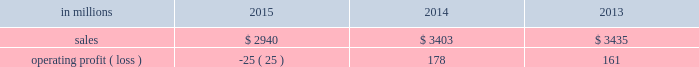Augusta , georgia mill and $ 2 million of costs associated with the sale of the shorewood business .
Consumer packaging .
North american consumer packaging net sales were $ 1.9 billion in 2015 compared with $ 2.0 billion in 2014 and $ 2.0 billion in 2013 .
Operating profits were $ 81 million ( $ 91 million excluding the cost associated with the planned conversion of our riegelwood mill to 100% ( 100 % ) pulp production , net of proceeds from the sale of the carolina coated bristols brand , and sheet plant closure costs ) in 2015 compared with $ 92 million ( $ 100 million excluding sheet plant closure costs ) in 2014 and $ 63 million ( $ 110 million excluding paper machine shutdown costs and costs related to the sale of the shorewood business ) in 2013 .
Coated paperboard sales volumes in 2015 were lower than in 2014 reflecting weaker market demand .
The business took about 77000 tons of market-related downtime in 2015 compared with about 41000 tons in 2014 .
Average sales price realizations increased modestly year over year as competitive pressures in the current year only partially offset the impact of sales price increases implemented in 2014 .
Input costs decreased for energy and chemicals , but wood costs increased .
Planned maintenance downtime costs were $ 10 million lower in 2015 .
Operating costs were higher , mainly due to inflation and overhead costs .
Foodservice sales volumes increased in 2015 compared with 2014 reflecting strong market demand .
Average sales margins increased due to lower resin costs and a more favorable mix .
Operating costs and distribution costs were both higher .
Looking ahead to the first quarter of 2016 , coated paperboard sales volumes are expected to be slightly lower than in the fourth quarter of 2015 due to our exit from the coated bristols market .
Average sales price realizations are expected to be flat , but margins should benefit from a more favorable product mix .
Input costs are expected to be higher for wood , chemicals and energy .
Planned maintenance downtime costs should be $ 4 million higher with a planned maintenance outage scheduled at our augusta mill in the first quarter .
Foodservice sales volumes are expected to be seasonally lower .
Average sales margins are expected to improve due to a more favorable mix .
Operating costs are expected to decrease .
European consumer packaging net sales in 2015 were $ 319 million compared with $ 365 million in 2014 and $ 380 million in 2013 .
Operating profits in 2015 were $ 87 million compared with $ 91 million in 2014 and $ 100 million in 2013 .
Sales volumes in 2015 compared with 2014 increased in europe , but decreased in russia .
Average sales margins improved in russia due to slightly higher average sales price realizations and a more favorable mix .
In europe average sales margins decreased reflecting lower average sales price realizations and an unfavorable mix .
Input costs were lower in europe , primarily for wood and energy , but were higher in russia , primarily for wood .
Looking forward to the first quarter of 2016 , compared with the fourth quarter of 2015 , sales volumes are expected to be stable .
Average sales price realizations are expected to be slightly higher in both russia and europe .
Input costs are expected to be flat , while operating costs are expected to increase .
Asian consumer packaging the company sold its 55% ( 55 % ) equity share in the ip-sun jv in october 2015 .
Net sales and operating profits presented below include results through september 30 , 2015 .
Net sales were $ 682 million in 2015 compared with $ 1.0 billion in 2014 and $ 1.1 billion in 2013 .
Operating profits in 2015 were a loss of $ 193 million ( a loss of $ 19 million excluding goodwill and other asset impairment costs ) compared with losses of $ 5 million in 2014 and $ 2 million in 2013 .
Sales volumes and average sales price realizations were lower in 2015 due to over-supplied market conditions and competitive pressures .
Average sales margins were also negatively impacted by a less favorable mix .
Input costs and freight costs were lower and operating costs also decreased .
On october 13 , 2015 , the company finalized the sale of its 55% ( 55 % ) interest in ip asia coated paperboard ( ip- sun jv ) business , within the company's consumer packaging segment , to its chinese coated board joint venture partner , shandong sun holding group co. , ltd .
For rmb 149 million ( approximately usd $ 23 million ) .
During the third quarter of 2015 , a determination was made that the current book value of the asset group exceeded its estimated fair value of $ 23 million , which was the agreed upon selling price .
The 2015 loss includes the net pre-tax impairment charge of $ 174 million ( $ 113 million after taxes ) .
A pre-tax charge of $ 186 million was recorded during the third quarter in the company's consumer packaging segment to write down the long-lived assets of this business to their estimated fair value .
In the fourth quarter of 2015 , upon the sale and corresponding deconsolidation of ip-sun jv from the company's consolidated balance sheet , final adjustments were made resulting in a reduction of the impairment of $ 12 million .
The amount of pre-tax losses related to noncontrolling interest of the ip-sun jv included in the company's consolidated statement of operations for the years ended december 31 , 2015 , 2014 and 2013 were $ 19 million , $ 12 million and $ 8 million , respectively .
The amount of pre-tax losses related to the ip-sun jv included in the company's .
What was the consumer packaging profit margin in 2013? 
Computations: (161 / 3435)
Answer: 0.04687. 